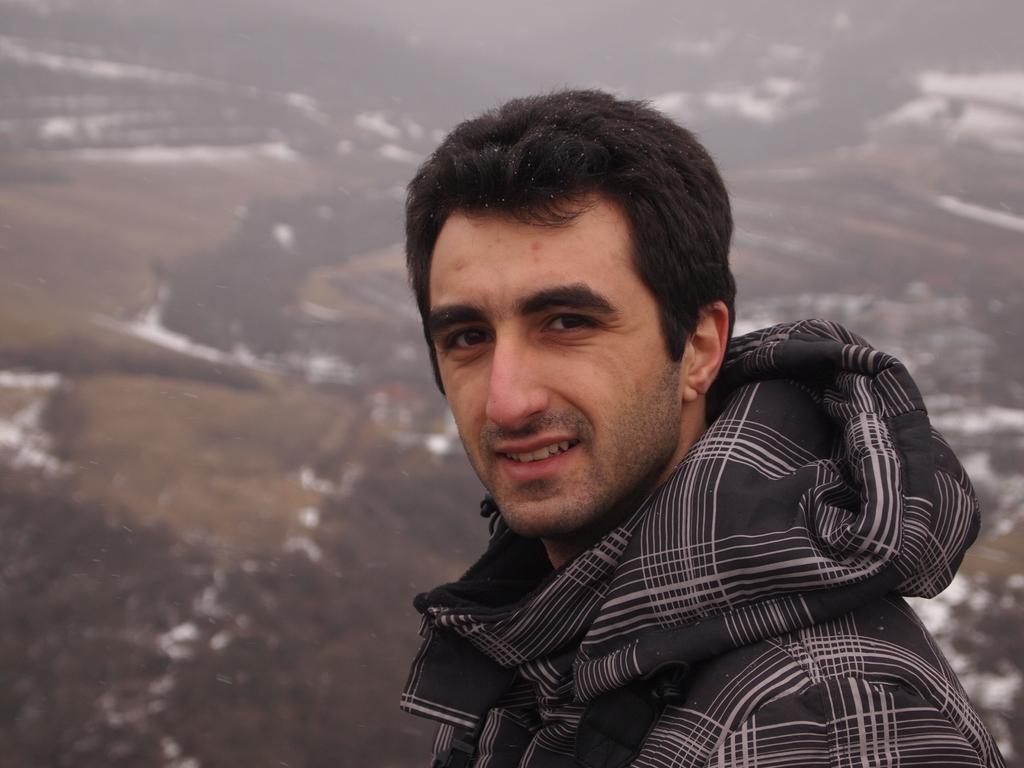How would you summarize this image in a sentence or two? In this picture I can see there is a man standing and he is wearing a black hoodie and he is smiling. There is snow on the floor in the backdrop and the backdrop is blurred. 